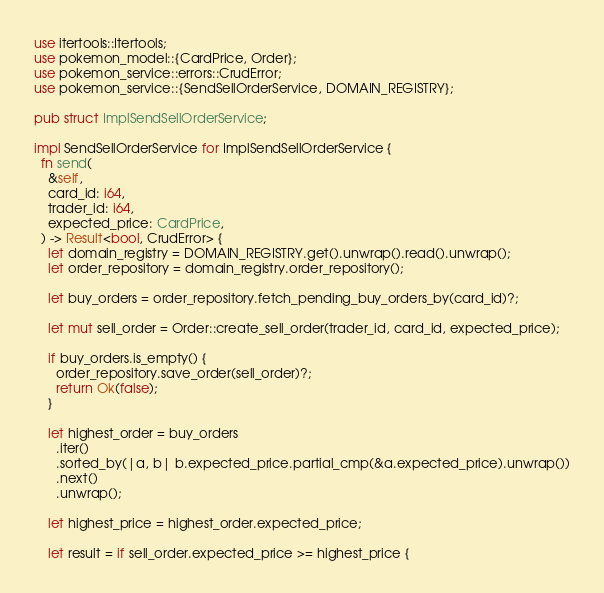Convert code to text. <code><loc_0><loc_0><loc_500><loc_500><_Rust_>use itertools::Itertools;
use pokemon_model::{CardPrice, Order};
use pokemon_service::errors::CrudError;
use pokemon_service::{SendSellOrderService, DOMAIN_REGISTRY};

pub struct ImplSendSellOrderService;

impl SendSellOrderService for ImplSendSellOrderService {
  fn send(
    &self,
    card_id: i64,
    trader_id: i64,
    expected_price: CardPrice,
  ) -> Result<bool, CrudError> {
    let domain_registry = DOMAIN_REGISTRY.get().unwrap().read().unwrap();
    let order_repository = domain_registry.order_repository();

    let buy_orders = order_repository.fetch_pending_buy_orders_by(card_id)?;

    let mut sell_order = Order::create_sell_order(trader_id, card_id, expected_price);

    if buy_orders.is_empty() {
      order_repository.save_order(sell_order)?;
      return Ok(false);
    }

    let highest_order = buy_orders
      .iter()
      .sorted_by(|a, b| b.expected_price.partial_cmp(&a.expected_price).unwrap())
      .next()
      .unwrap();

    let highest_price = highest_order.expected_price;

    let result = if sell_order.expected_price >= highest_price {</code> 